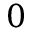Convert formula to latex. <formula><loc_0><loc_0><loc_500><loc_500>0</formula> 